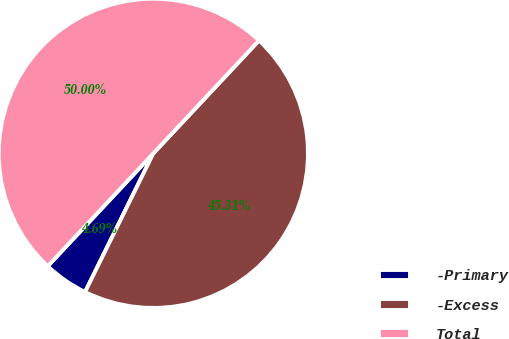Convert chart to OTSL. <chart><loc_0><loc_0><loc_500><loc_500><pie_chart><fcel>-Primary<fcel>-Excess<fcel>Total<nl><fcel>4.69%<fcel>45.31%<fcel>50.0%<nl></chart> 